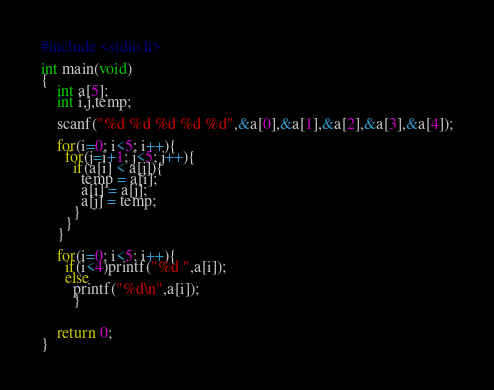<code> <loc_0><loc_0><loc_500><loc_500><_C_>#include <stdio.h>

int main(void)
{
	int a[5];
	int i,j,temp;

	scanf("%d %d %d %d %d",&a[0],&a[1],&a[2],&a[3],&a[4]);

	for(i=0; i<5; i++){
	  for(j=i+1; j<5; j++){
	    if(a[i] < a[j]){
	      temp = a[i];
	      a[i] = a[j];
	      a[j] = temp;
	    }
	  }
	}

	for(i=0; i<5; i++){
	  if(i<4)printf("%d ",a[i]);
	  else
	    printf("%d\n",a[i]);
        }


	return 0;
}</code> 